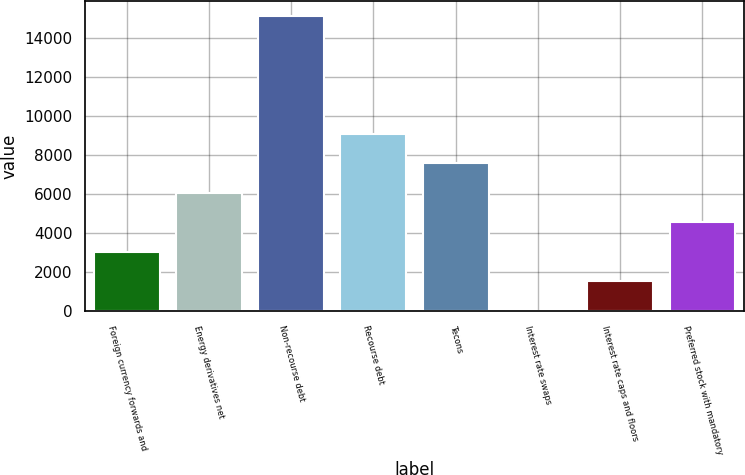Convert chart. <chart><loc_0><loc_0><loc_500><loc_500><bar_chart><fcel>Foreign currency forwards and<fcel>Energy derivatives net<fcel>Non-recourse debt<fcel>Recourse debt<fcel>Tecons<fcel>Interest rate swaps<fcel>Interest rate caps and floors<fcel>Preferred stock with mandatory<nl><fcel>3033.2<fcel>6064.4<fcel>15158<fcel>9095.6<fcel>7580<fcel>2<fcel>1517.6<fcel>4548.8<nl></chart> 